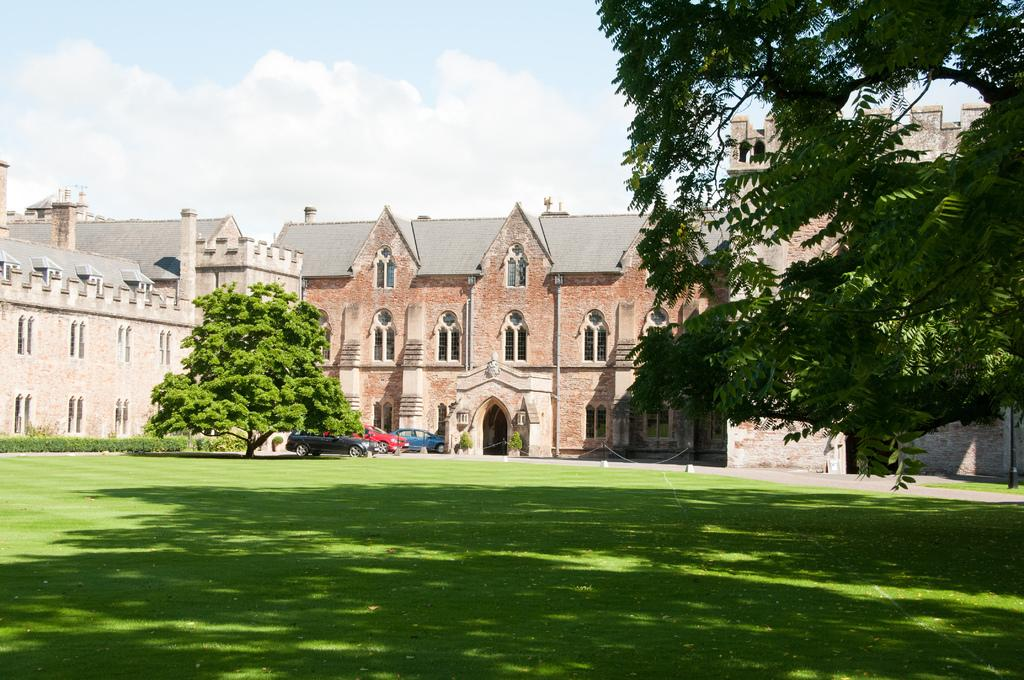What type of structures can be seen in the image? There are buildings in the image. What type of vegetation is present in the image? There are trees, plants, and grass in the image. How many vehicles are visible in the image? There are three vehicles in the image. What is visible at the top of the image? The sky is visible at the top of the image. What type of bun is being used to hold the destruction in the image? There is no bun or destruction present in the image. How many quinces are visible on the trees in the image? There are no quinces visible in the image; only trees and plants are present. 